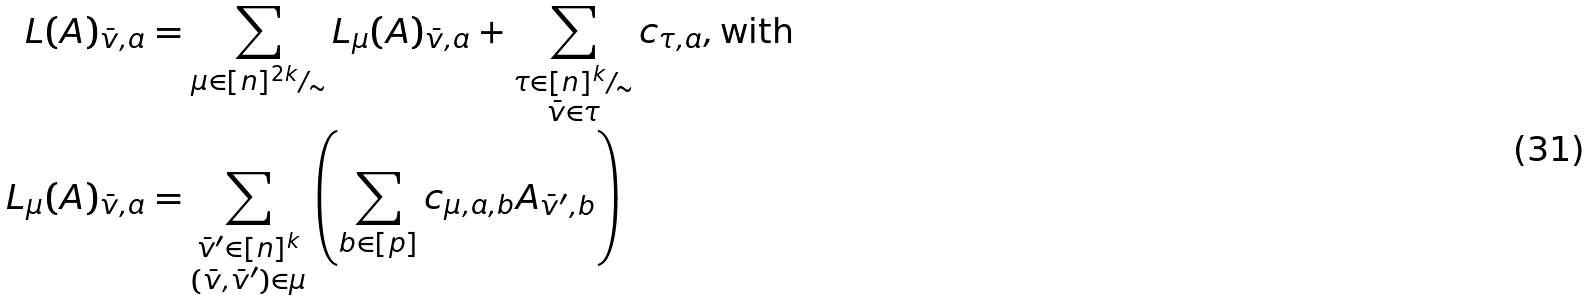Convert formula to latex. <formula><loc_0><loc_0><loc_500><loc_500>L ( A ) _ { \bar { v } , a } & = \sum _ { \mu \in [ n ] ^ { 2 k } / _ { \sim } } L _ { \mu } ( A ) _ { \bar { v } , a } + \sum _ { \substack { \tau \in [ n ] ^ { k } / _ { \sim } \\ \bar { v } \in \tau } } c _ { \tau , a } , \text {with} \\ L _ { \mu } ( A ) _ { \bar { v } , a } & = \sum _ { \substack { \bar { v } ^ { \prime } \in [ n ] ^ { k } \\ ( \bar { v } , \bar { v } ^ { \prime } ) \in \mu } } \left ( \sum _ { b \in [ p ] } c _ { \mu , a , b } A _ { \bar { v } ^ { \prime } , b } \right )</formula> 